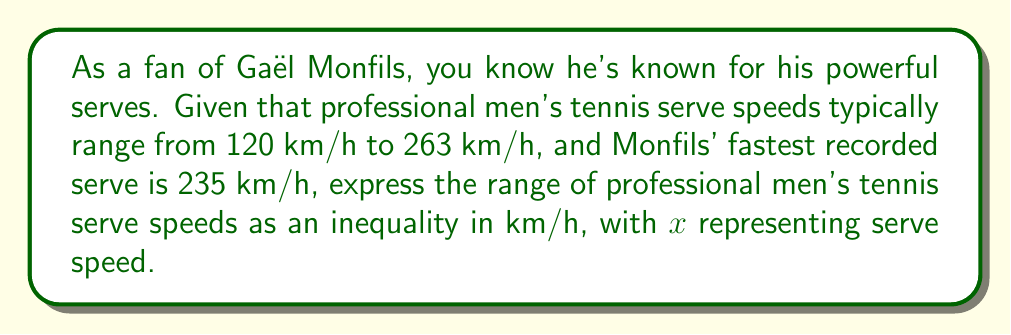Help me with this question. To express the range of serve speeds as an inequality, we need to use the given information:

1. The lower bound of professional men's tennis serve speeds is 120 km/h.
2. The upper bound of professional men's tennis serve speeds is 263 km/h.
3. The variable $x$ represents serve speed in km/h.

We can express this range using a compound inequality:

$$120 \leq x \leq 263$$

This inequality means that the serve speed $x$ is greater than or equal to 120 km/h AND less than or equal to 263 km/h.

It's interesting to note that Gaël Monfils' fastest recorded serve of 235 km/h falls within this range, as we would expect for a professional player:

$$120 \leq 235 \leq 263$$

This inequality correctly represents the range of serve speeds for professional men's tennis players, including stars like Monfils.
Answer: $$120 \leq x \leq 263$$ 